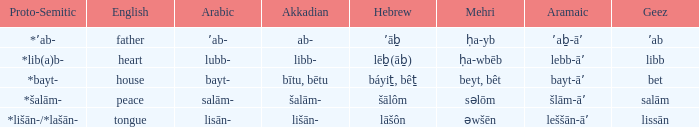If the geez is libb, what is the akkadian? Libb-. Help me parse the entirety of this table. {'header': ['Proto-Semitic', 'English', 'Arabic', 'Akkadian', 'Hebrew', 'Mehri', 'Aramaic', 'Geez'], 'rows': [['*ʼab-', 'father', 'ʼab-', 'ab-', 'ʼāḇ', 'ḥa-yb', 'ʼaḇ-āʼ', 'ʼab'], ['*lib(a)b-', 'heart', 'lubb-', 'libb-', 'lēḇ(āḇ)', 'ḥa-wbēb', 'lebb-āʼ', 'libb'], ['*bayt-', 'house', 'bayt-', 'bītu, bētu', 'báyiṯ, bêṯ', 'beyt, bêt', 'bayt-āʼ', 'bet'], ['*šalām-', 'peace', 'salām-', 'šalām-', 'šālôm', 'səlōm', 'šlām-āʼ', 'salām'], ['*lišān-/*lašān-', 'tongue', 'lisān-', 'lišān-', 'lāšôn', 'əwšēn', 'leššān-āʼ', 'lissān']]} 